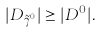Convert formula to latex. <formula><loc_0><loc_0><loc_500><loc_500>| D _ { \tilde { \gamma } ^ { 0 } } | \geq | D ^ { 0 } | .</formula> 